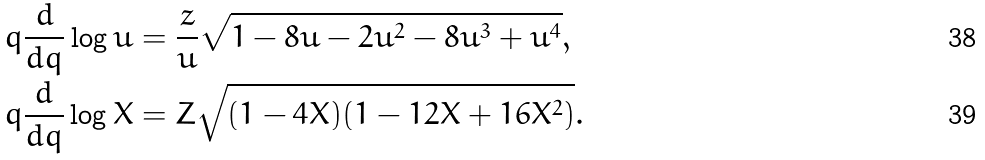<formula> <loc_0><loc_0><loc_500><loc_500>q \frac { d } { d q } \log { u } & = \frac { z } { u } \sqrt { 1 - 8 u - 2 u ^ { 2 } - 8 u ^ { 3 } + u ^ { 4 } } , \\ q \frac { d } { d q } \log { X } & = Z \sqrt { ( 1 - 4 X ) ( 1 - 1 2 X + 1 6 X ^ { 2 } ) } .</formula> 